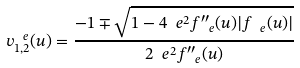<formula> <loc_0><loc_0><loc_500><loc_500>v ^ { \ e } _ { 1 , 2 } ( u ) = \frac { - 1 \mp \sqrt { 1 - 4 \ e ^ { 2 } f ^ { \prime \prime } _ { \ e } ( u ) | f _ { \ e } ( u ) | } } { 2 \ e ^ { 2 } f ^ { \prime \prime } _ { \ e } ( u ) }</formula> 